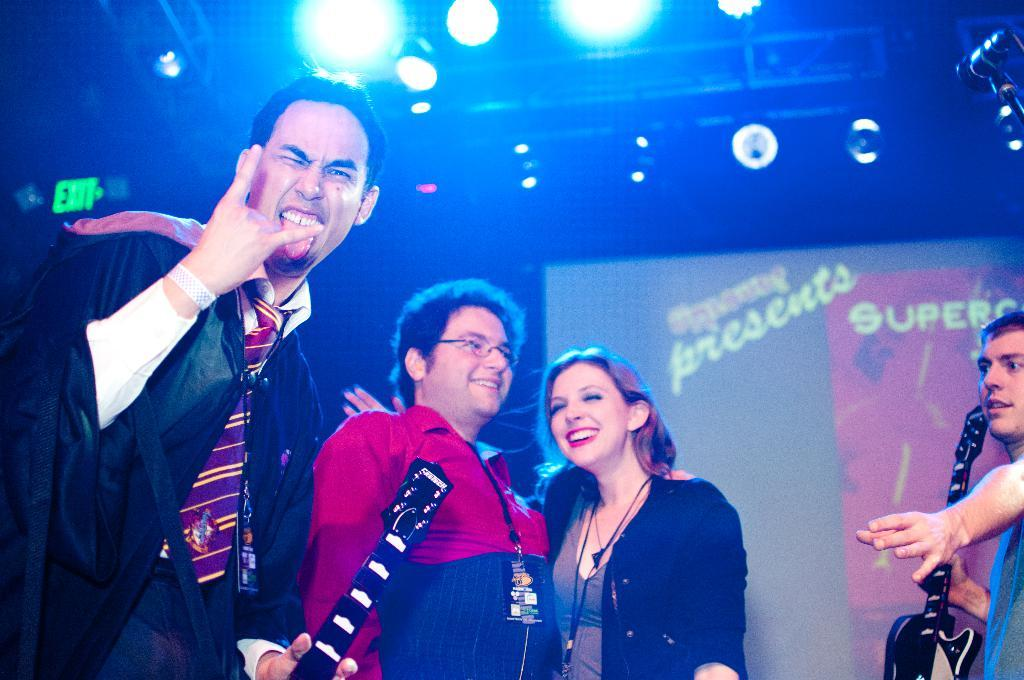How many people are in the image? There are three people in the image. What are the people doing in the image? The people are standing and smiling. Can you describe the lighting in the image? There is a light visible at the top of the image. What type of books are the people reading in the image? There are no books or reading activity present in the image. 